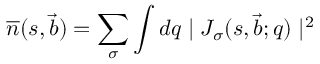<formula> <loc_0><loc_0><loc_500><loc_500>\overline { n } ( s , \vec { b } ) = \sum _ { \sigma } \int d q | J _ { \sigma } ( s , \vec { b } ; q ) | ^ { 2 }</formula> 